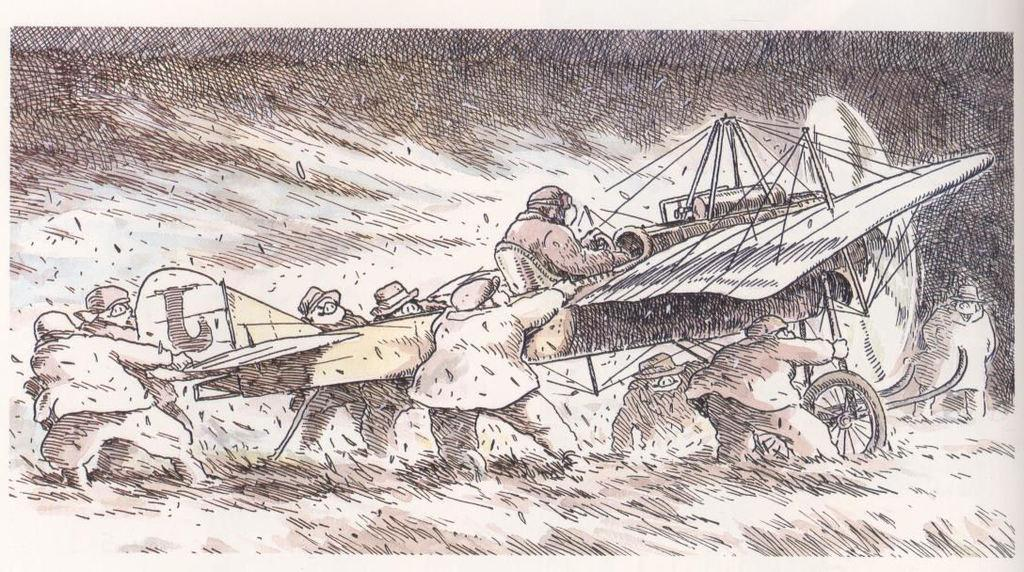What is depicted in the image? There is a sketch of people in the image. What are the people holding in the sketch? The people are holding an airplane. Is there anyone sitting on the airplane in the sketch? Yes, there is a person sitting on the airplane in the sketch. What type of boot is being used to lift the airplane in the image? There is no boot or lifting action depicted in the image; it features a sketch of people holding an airplane. How many pets are visible in the image? There are no pets present in the image; it features a sketch of people holding an airplane. 